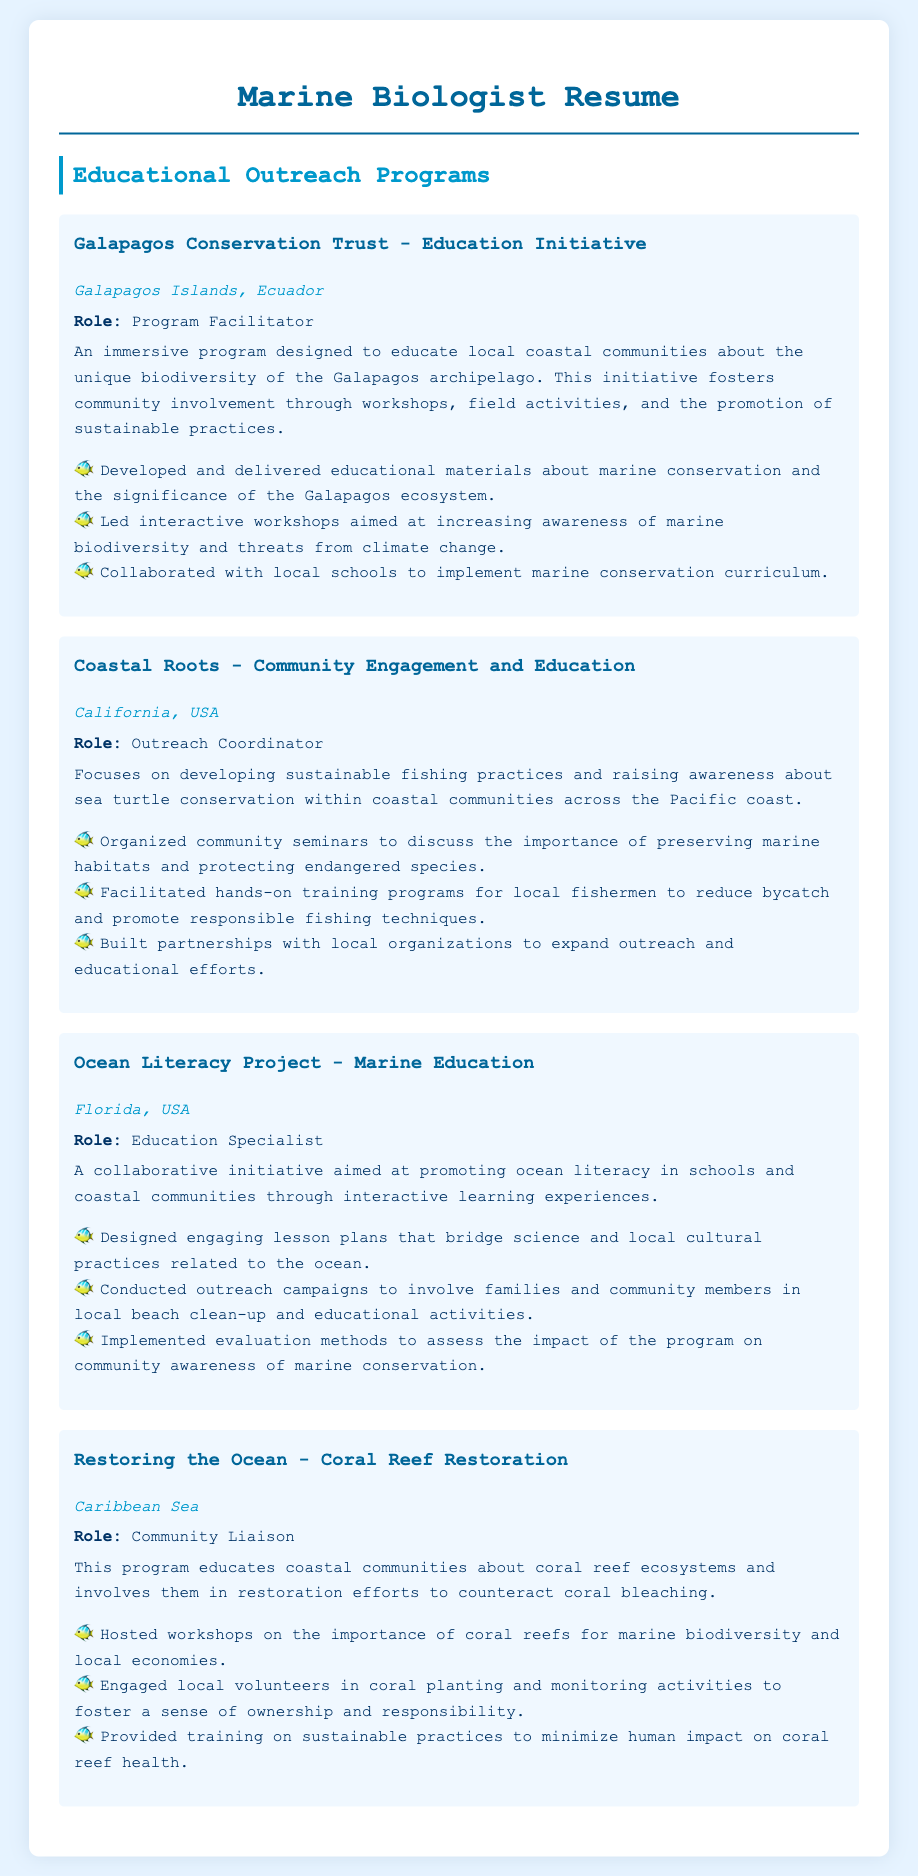what is the role of the person in the Galapagos Conservation Trust? The role listed in the document for the Galapagos Conservation Trust is "Program Facilitator."
Answer: Program Facilitator what is the focus of the Coastal Roots program? The Coastal Roots program focuses on developing sustainable fishing practices and raising awareness about sea turtle conservation.
Answer: Sustainable fishing practices and sea turtle conservation where is the Ocean Literacy Project located? The document states that the Ocean Literacy Project is located in Florida, USA.
Answer: Florida, USA what type of activities does the Restoring the Ocean program involve? The Restoring the Ocean program involves coral planting and monitoring activities.
Answer: Coral planting and monitoring how many educational outreach programs are mentioned in the document? There are four educational outreach programs listed in the resume.
Answer: Four which program includes partnering with local organizations? The Outreach Coordinator role in the Coastal Roots program includes building partnerships with local organizations.
Answer: Coastal Roots what is the main goal of the Galapagos Conservation Trust - Education Initiative? The main goal is to educate local coastal communities about the unique biodiversity of the Galapagos archipelago.
Answer: Educate local coastal communities about biodiversity what is the role of the person in the Caribbean Sea program? The role listed for the Caribbean Sea program is "Community Liaison."
Answer: Community Liaison what type of educational materials were developed in the Galapagos program? The educational materials developed were about marine conservation and the significance of the Galapagos ecosystem.
Answer: Marine conservation and significance of the Galapagos ecosystem 